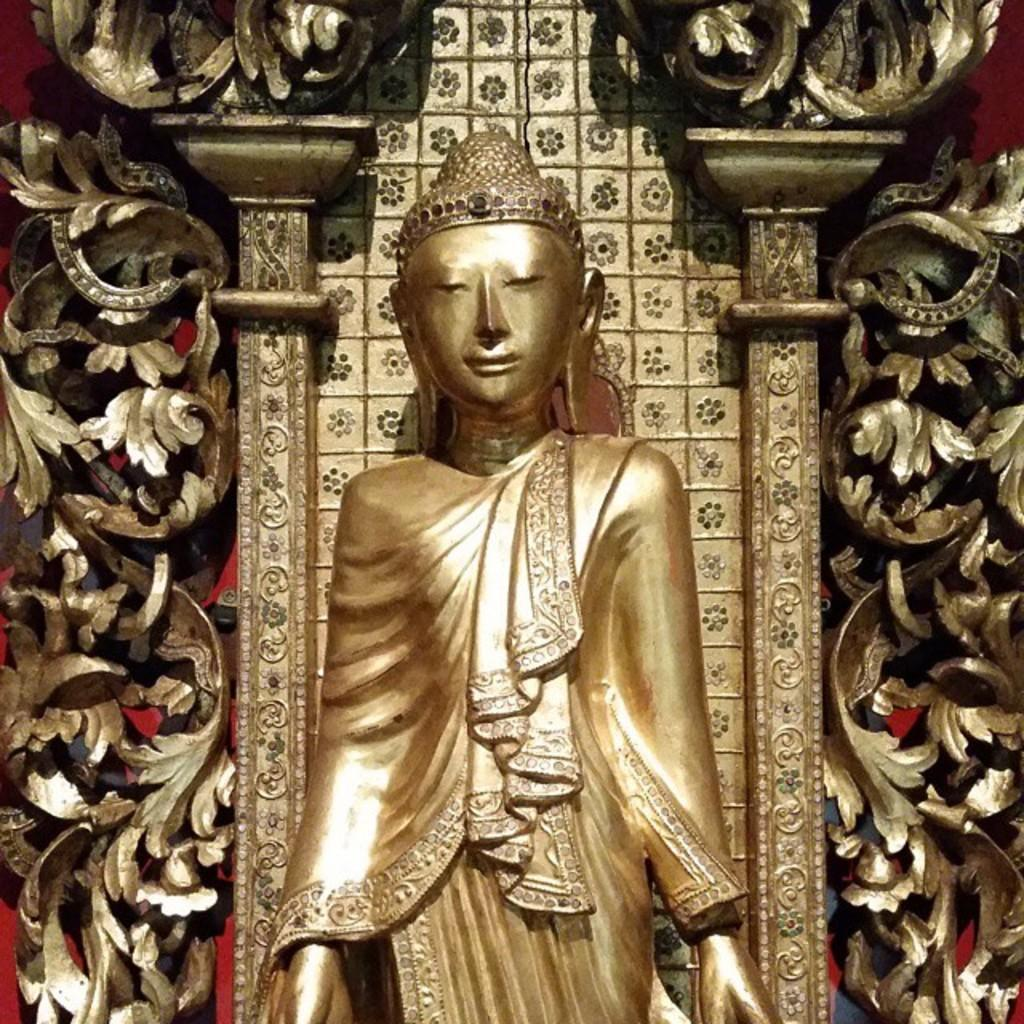What is the main subject of the image? There is a sculpture in the image. Can you describe the background of the image? There is a gold color design in the background of the image. How far does the hammer travel in the image? There is no hammer present in the image, so it cannot be determined how far it might travel. 